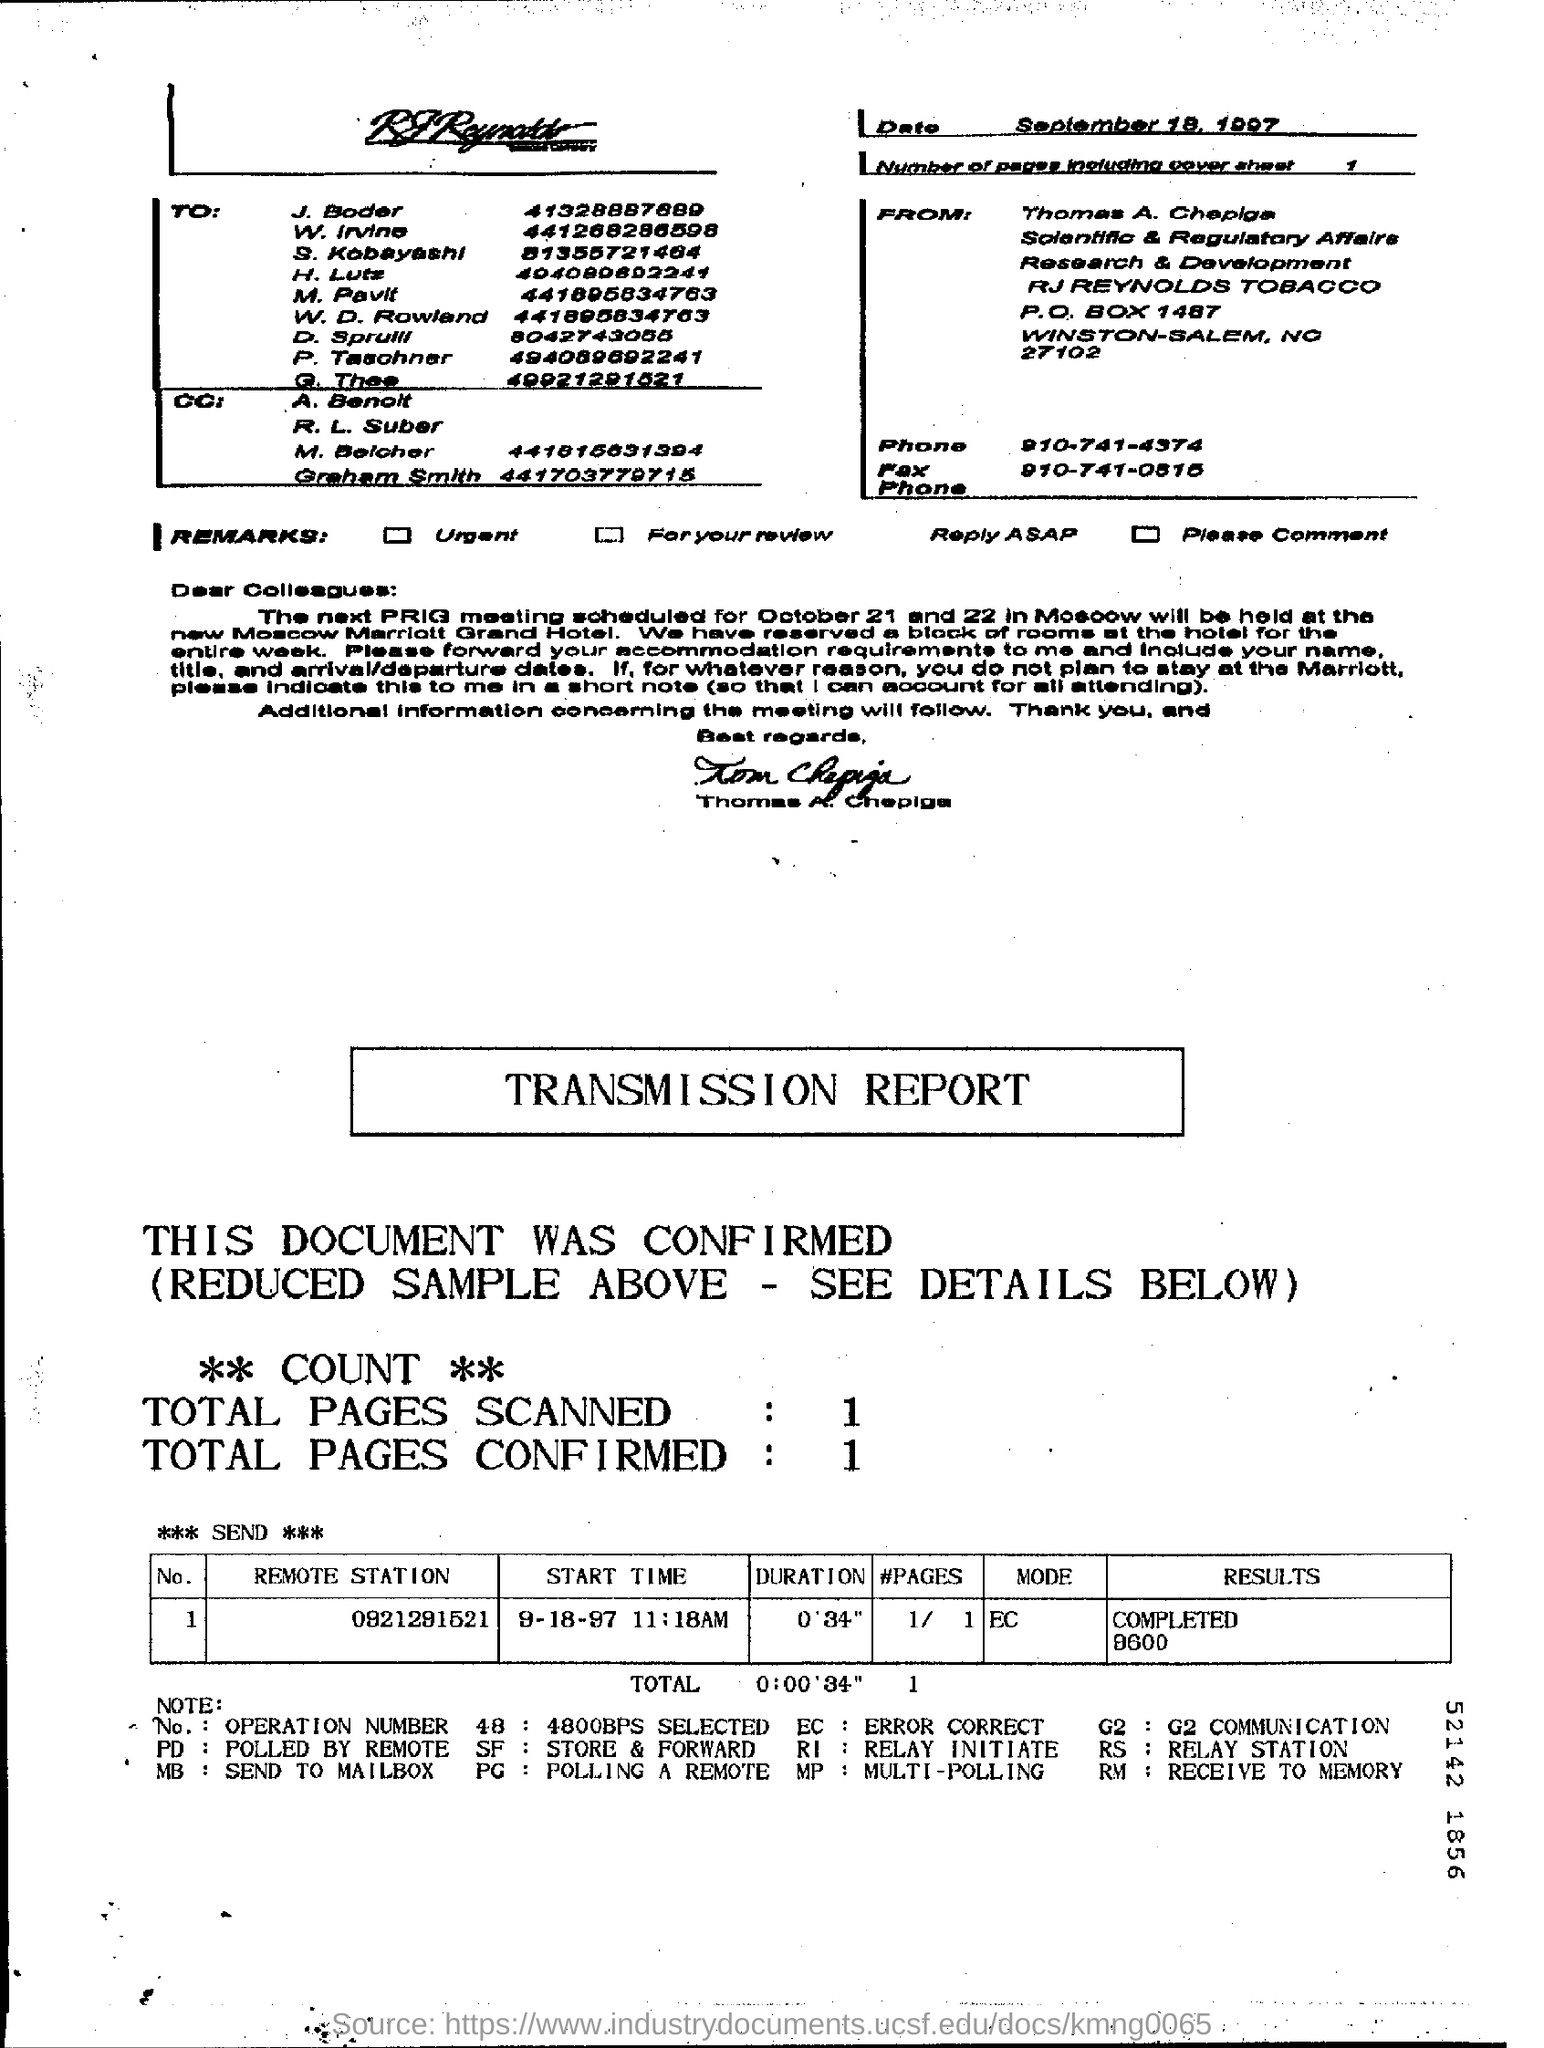Outline some significant characteristics in this image. There are 1 to n total number of pages confirmed. To what extent are all pages scanned? The P.O. box number of RJ Reynolds Tobacco is 1487. 